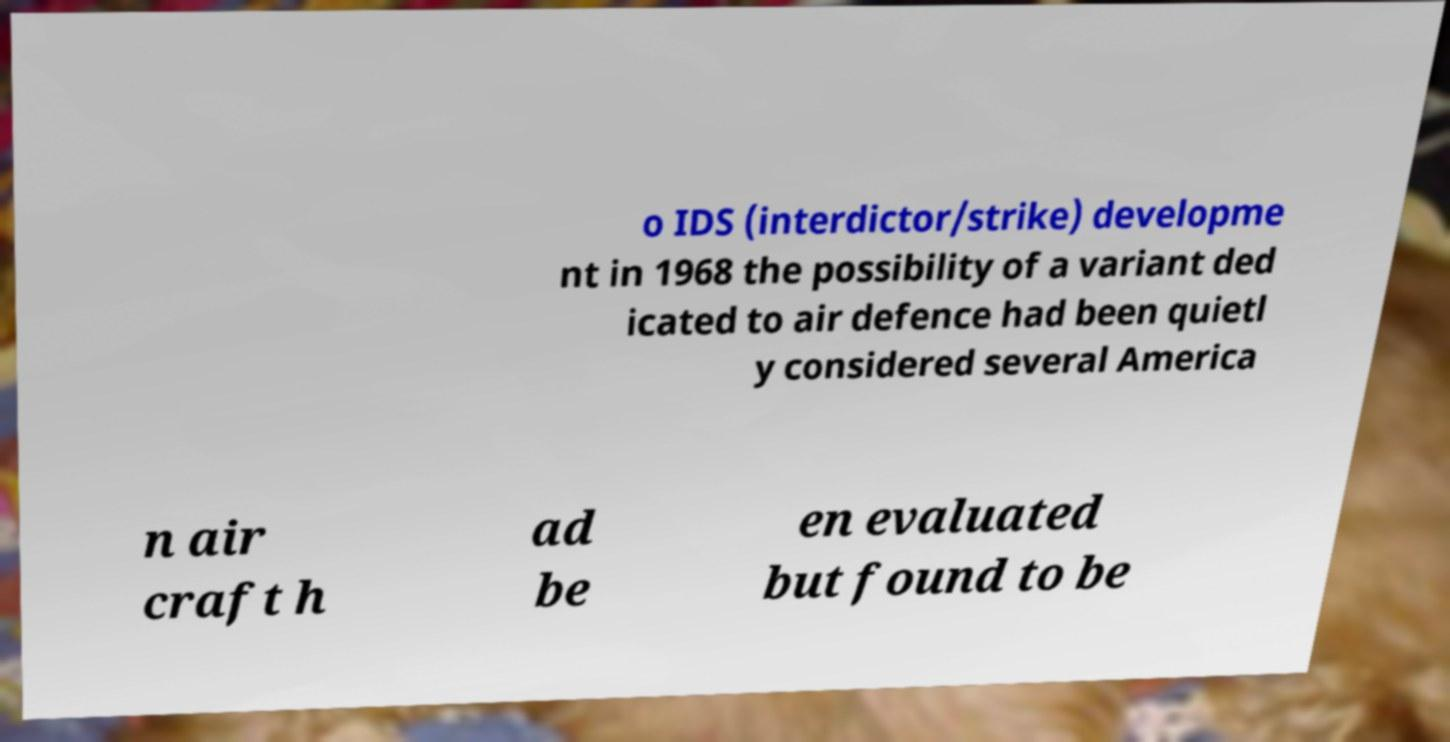Please identify and transcribe the text found in this image. o IDS (interdictor/strike) developme nt in 1968 the possibility of a variant ded icated to air defence had been quietl y considered several America n air craft h ad be en evaluated but found to be 